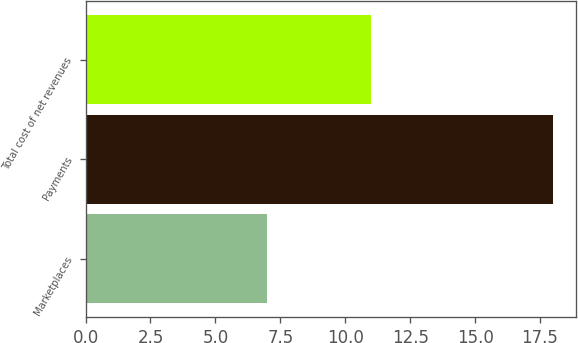Convert chart. <chart><loc_0><loc_0><loc_500><loc_500><bar_chart><fcel>Marketplaces<fcel>Payments<fcel>Total cost of net revenues<nl><fcel>7<fcel>18<fcel>11<nl></chart> 